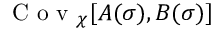Convert formula to latex. <formula><loc_0><loc_0><loc_500><loc_500>C o v _ { \chi } [ A ( \sigma ) , B ( \sigma ) ]</formula> 